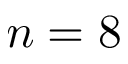<formula> <loc_0><loc_0><loc_500><loc_500>n = 8</formula> 